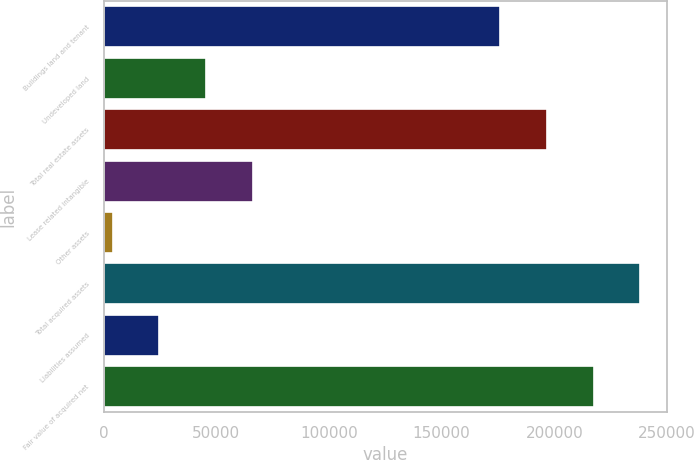<chart> <loc_0><loc_0><loc_500><loc_500><bar_chart><fcel>Buildings land and tenant<fcel>Undeveloped land<fcel>Total real estate assets<fcel>Lease related intangible<fcel>Other assets<fcel>Total acquired assets<fcel>Liabilities assumed<fcel>Fair value of acquired net<nl><fcel>176038<fcel>45364.6<fcel>196727<fcel>66053.4<fcel>3987<fcel>238104<fcel>24675.8<fcel>217416<nl></chart> 